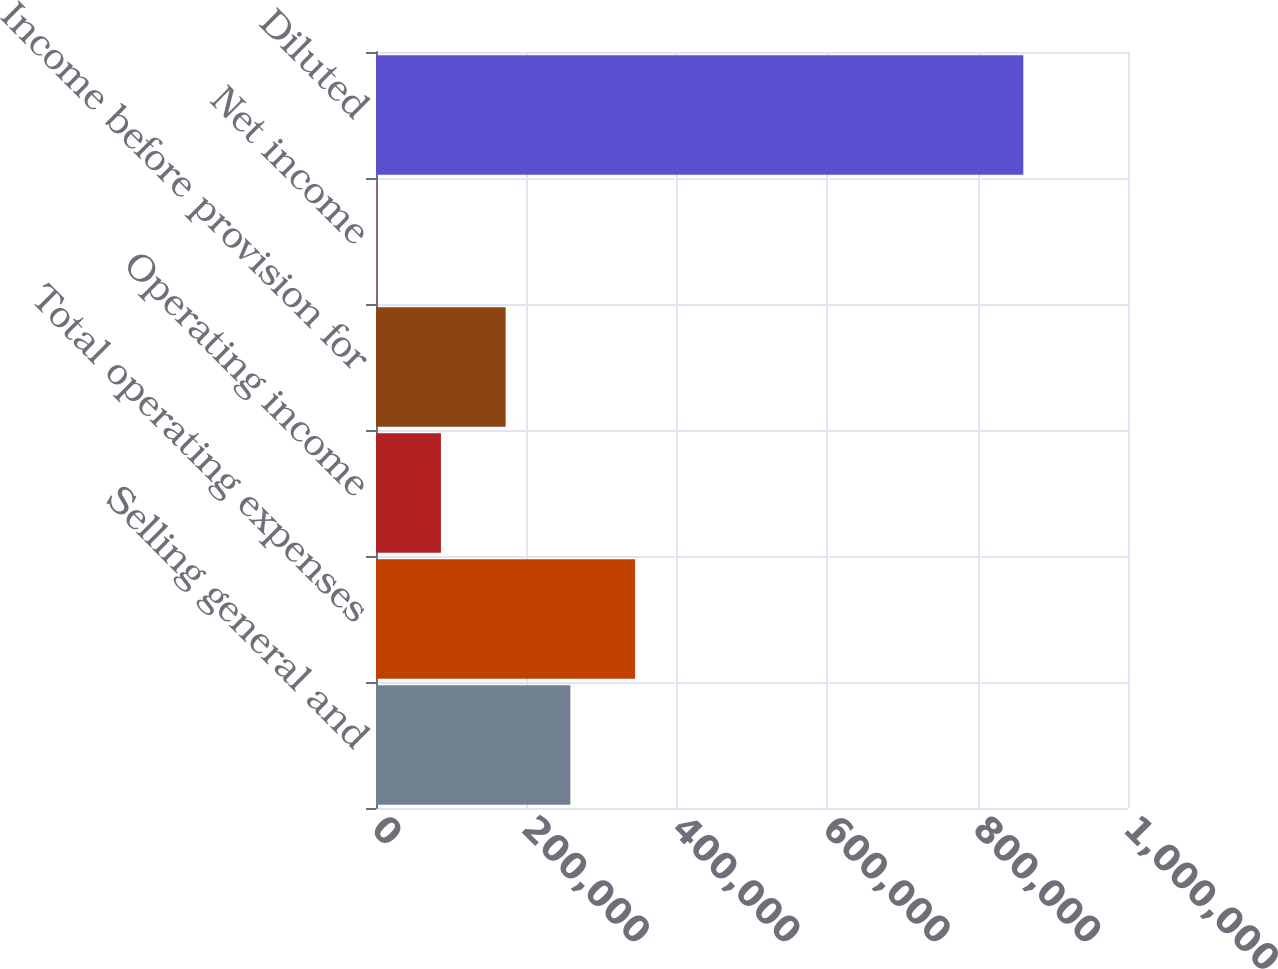<chart> <loc_0><loc_0><loc_500><loc_500><bar_chart><fcel>Selling general and<fcel>Total operating expenses<fcel>Operating income<fcel>Income before provision for<fcel>Net income<fcel>Diluted<nl><fcel>258464<fcel>344513<fcel>86367.4<fcel>172416<fcel>319<fcel>860803<nl></chart> 